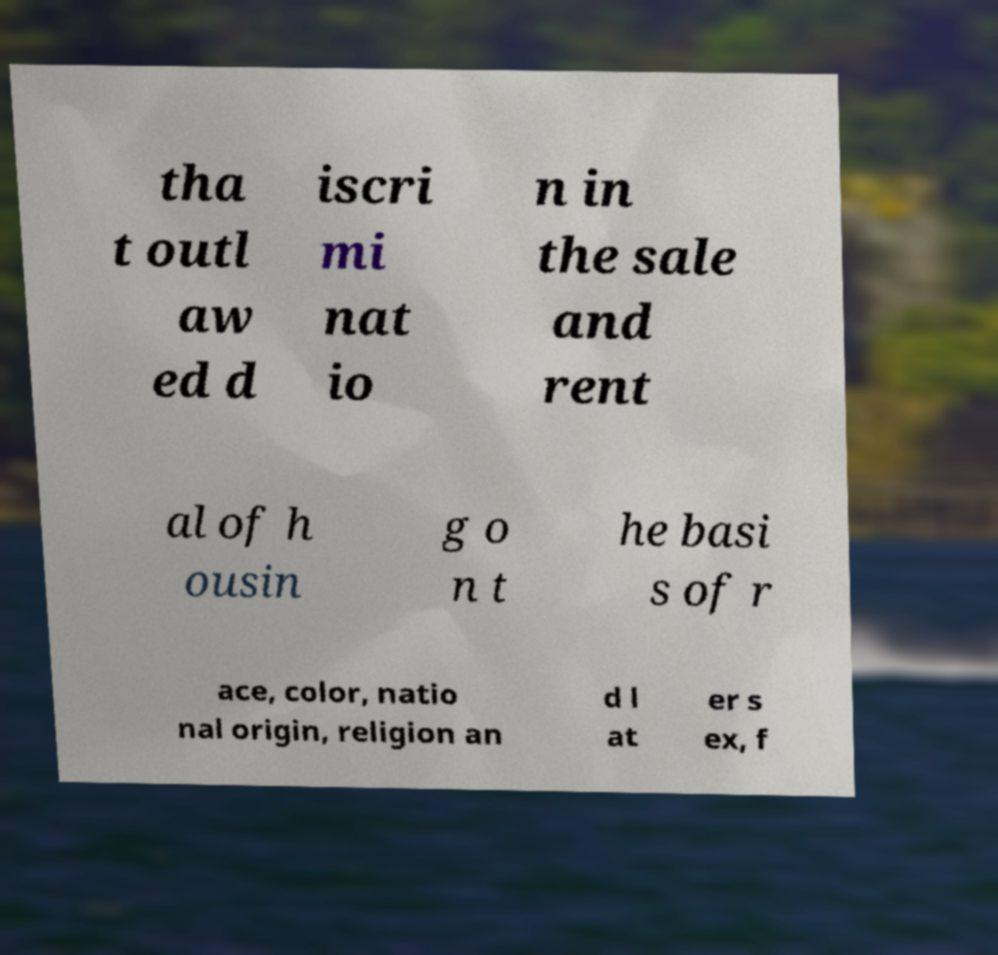Can you read and provide the text displayed in the image?This photo seems to have some interesting text. Can you extract and type it out for me? tha t outl aw ed d iscri mi nat io n in the sale and rent al of h ousin g o n t he basi s of r ace, color, natio nal origin, religion an d l at er s ex, f 